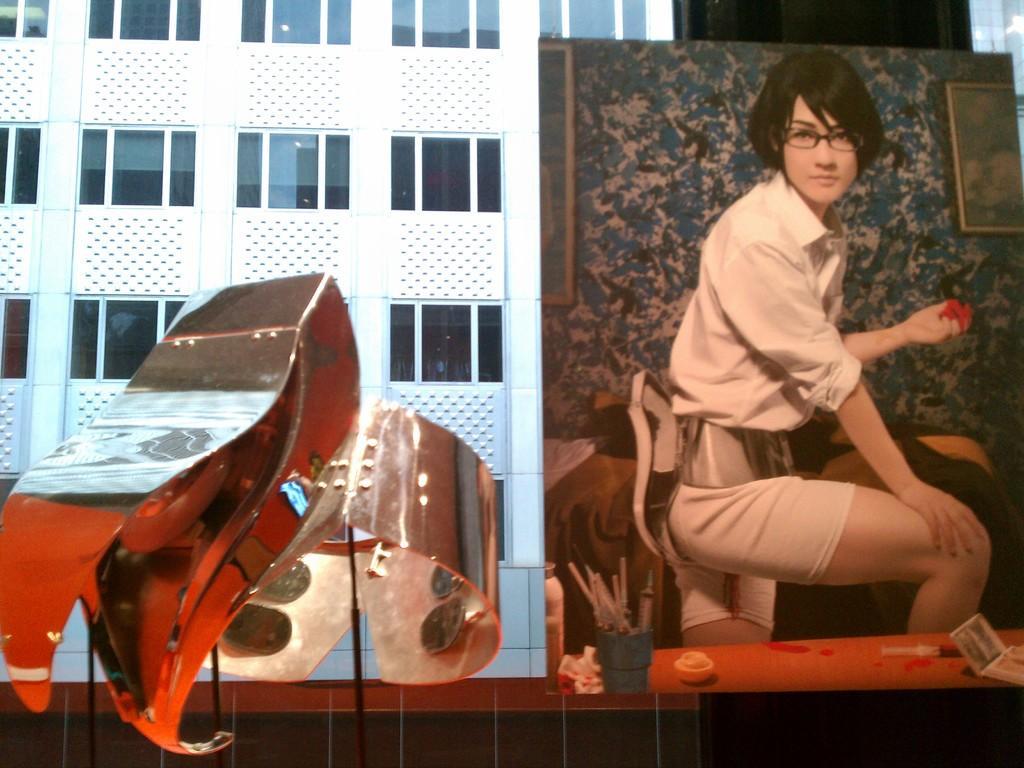How would you summarize this image in a sentence or two? In this image in the front there is an object and there is a poster. In the poster there are objects and there are frames on the wall and there is a person standing and holding an object in hand. In the background there is a building. 